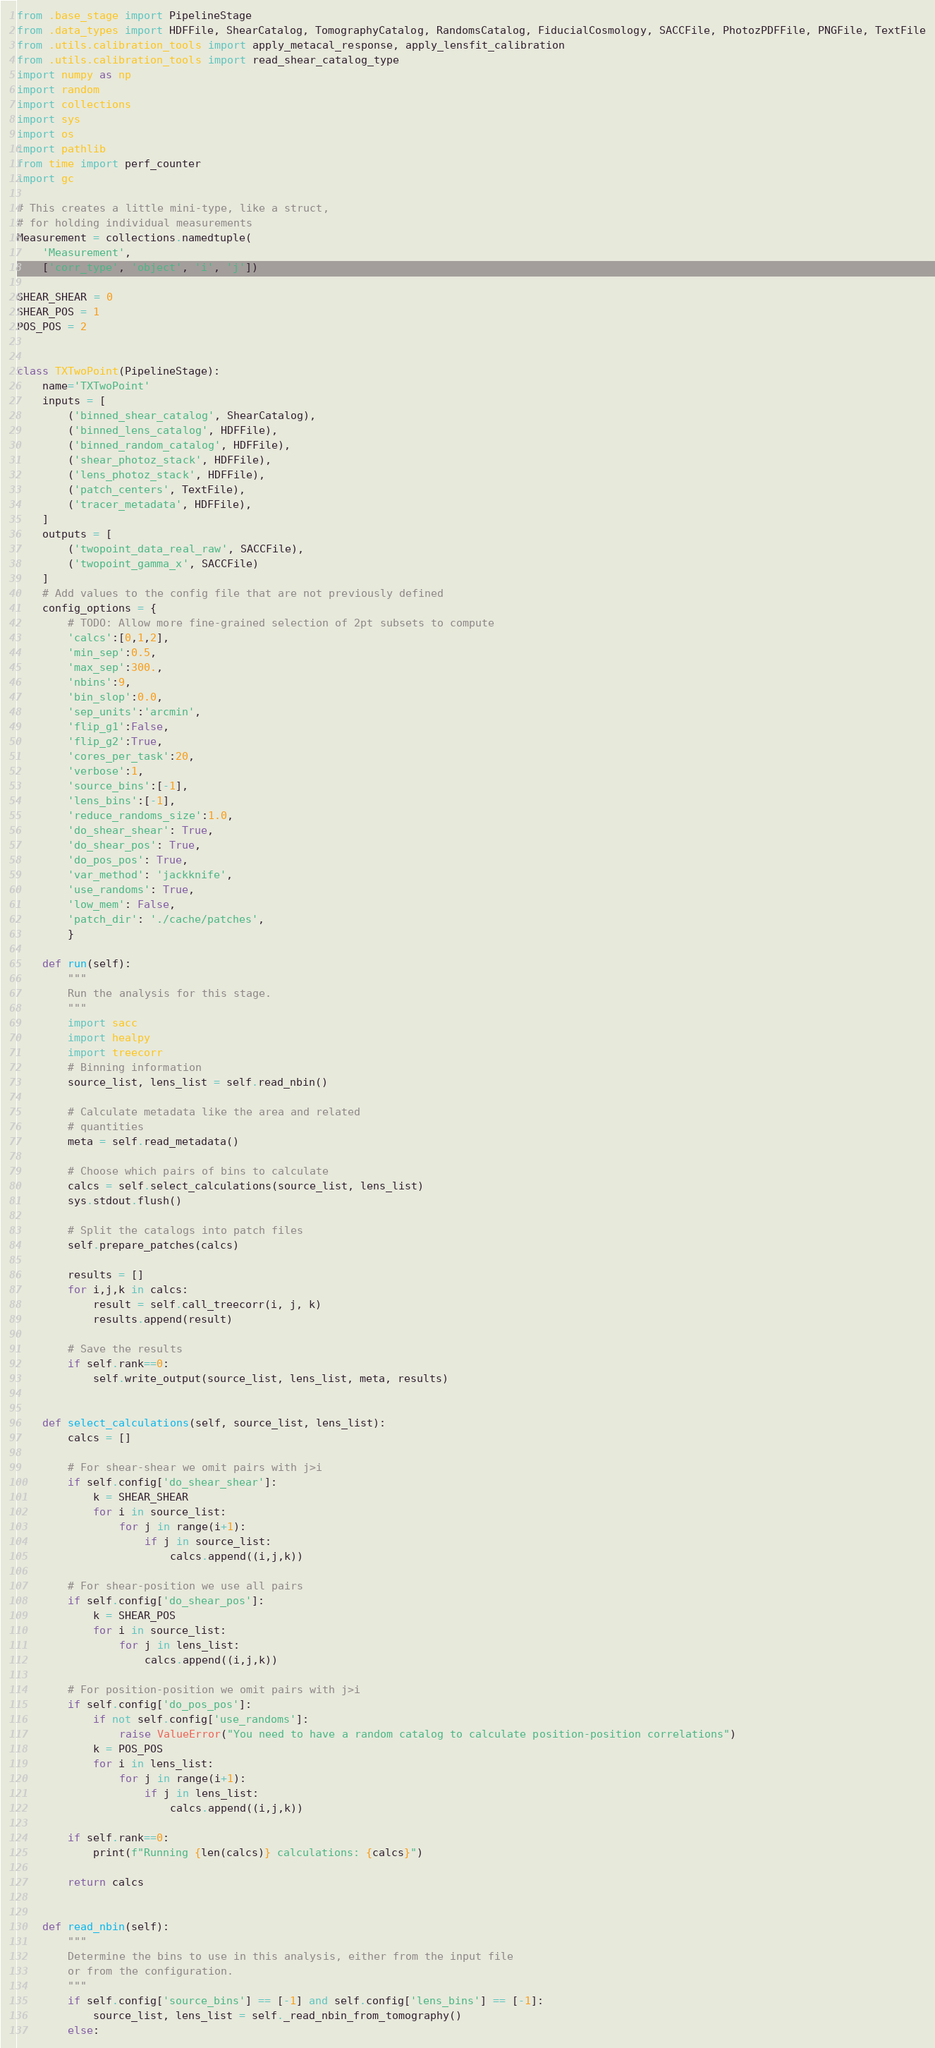Convert code to text. <code><loc_0><loc_0><loc_500><loc_500><_Python_>from .base_stage import PipelineStage
from .data_types import HDFFile, ShearCatalog, TomographyCatalog, RandomsCatalog, FiducialCosmology, SACCFile, PhotozPDFFile, PNGFile, TextFile
from .utils.calibration_tools import apply_metacal_response, apply_lensfit_calibration 
from .utils.calibration_tools import read_shear_catalog_type
import numpy as np
import random
import collections
import sys
import os
import pathlib
from time import perf_counter
import gc

# This creates a little mini-type, like a struct,
# for holding individual measurements
Measurement = collections.namedtuple(
    'Measurement',
    ['corr_type', 'object', 'i', 'j'])

SHEAR_SHEAR = 0
SHEAR_POS = 1
POS_POS = 2


class TXTwoPoint(PipelineStage):
    name='TXTwoPoint'
    inputs = [
        ('binned_shear_catalog', ShearCatalog),
        ('binned_lens_catalog', HDFFile),
        ('binned_random_catalog', HDFFile),
        ('shear_photoz_stack', HDFFile),
        ('lens_photoz_stack', HDFFile),
        ('patch_centers', TextFile),
        ('tracer_metadata', HDFFile),
    ]
    outputs = [
        ('twopoint_data_real_raw', SACCFile),
        ('twopoint_gamma_x', SACCFile)
    ]
    # Add values to the config file that are not previously defined
    config_options = {
        # TODO: Allow more fine-grained selection of 2pt subsets to compute
        'calcs':[0,1,2],
        'min_sep':0.5,
        'max_sep':300.,
        'nbins':9,
        'bin_slop':0.0,
        'sep_units':'arcmin',
        'flip_g1':False,
        'flip_g2':True,
        'cores_per_task':20,
        'verbose':1,
        'source_bins':[-1],
        'lens_bins':[-1],
        'reduce_randoms_size':1.0,
        'do_shear_shear': True,
        'do_shear_pos': True,
        'do_pos_pos': True,
        'var_method': 'jackknife',
        'use_randoms': True,
        'low_mem': False,
        'patch_dir': './cache/patches',
        }

    def run(self):
        """
        Run the analysis for this stage.
        """
        import sacc
        import healpy
        import treecorr
        # Binning information
        source_list, lens_list = self.read_nbin()

        # Calculate metadata like the area and related
        # quantities
        meta = self.read_metadata()

        # Choose which pairs of bins to calculate
        calcs = self.select_calculations(source_list, lens_list)
        sys.stdout.flush()

        # Split the catalogs into patch files
        self.prepare_patches(calcs)

        results = []
        for i,j,k in calcs:
            result = self.call_treecorr(i, j, k)
            results.append(result)

        # Save the results
        if self.rank==0:
            self.write_output(source_list, lens_list, meta, results)


    def select_calculations(self, source_list, lens_list):
        calcs = []

        # For shear-shear we omit pairs with j>i
        if self.config['do_shear_shear']:
            k = SHEAR_SHEAR
            for i in source_list:
                for j in range(i+1):
                    if j in source_list:
                        calcs.append((i,j,k))
        
        # For shear-position we use all pairs
        if self.config['do_shear_pos']:
            k = SHEAR_POS
            for i in source_list:
                for j in lens_list:
                    calcs.append((i,j,k))

        # For position-position we omit pairs with j>i
        if self.config['do_pos_pos']:
            if not self.config['use_randoms']:
                raise ValueError("You need to have a random catalog to calculate position-position correlations")
            k = POS_POS
            for i in lens_list:
                for j in range(i+1):
                    if j in lens_list:
                        calcs.append((i,j,k))

        if self.rank==0:
            print(f"Running {len(calcs)} calculations: {calcs}")

        return calcs


    def read_nbin(self):
        """
        Determine the bins to use in this analysis, either from the input file
        or from the configuration.
        """
        if self.config['source_bins'] == [-1] and self.config['lens_bins'] == [-1]:
            source_list, lens_list = self._read_nbin_from_tomography()
        else:</code> 